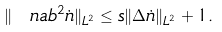<formula> <loc_0><loc_0><loc_500><loc_500>\| \ n a b ^ { 2 } \dot { n } \| _ { L ^ { 2 } } \leq s \| \Delta \dot { n } \| _ { L ^ { 2 } } + 1 .</formula> 